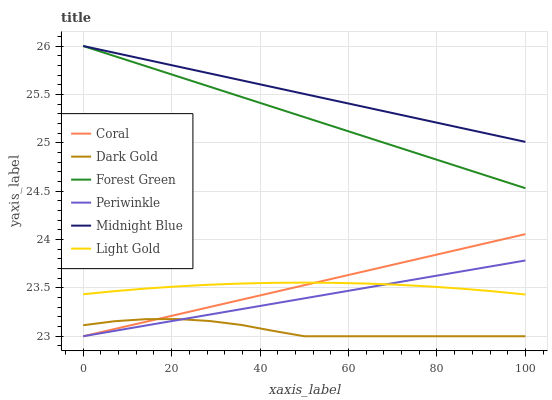Does Coral have the minimum area under the curve?
Answer yes or no. No. Does Coral have the maximum area under the curve?
Answer yes or no. No. Is Dark Gold the smoothest?
Answer yes or no. No. Is Coral the roughest?
Answer yes or no. No. Does Forest Green have the lowest value?
Answer yes or no. No. Does Coral have the highest value?
Answer yes or no. No. Is Coral less than Forest Green?
Answer yes or no. Yes. Is Forest Green greater than Dark Gold?
Answer yes or no. Yes. Does Coral intersect Forest Green?
Answer yes or no. No. 